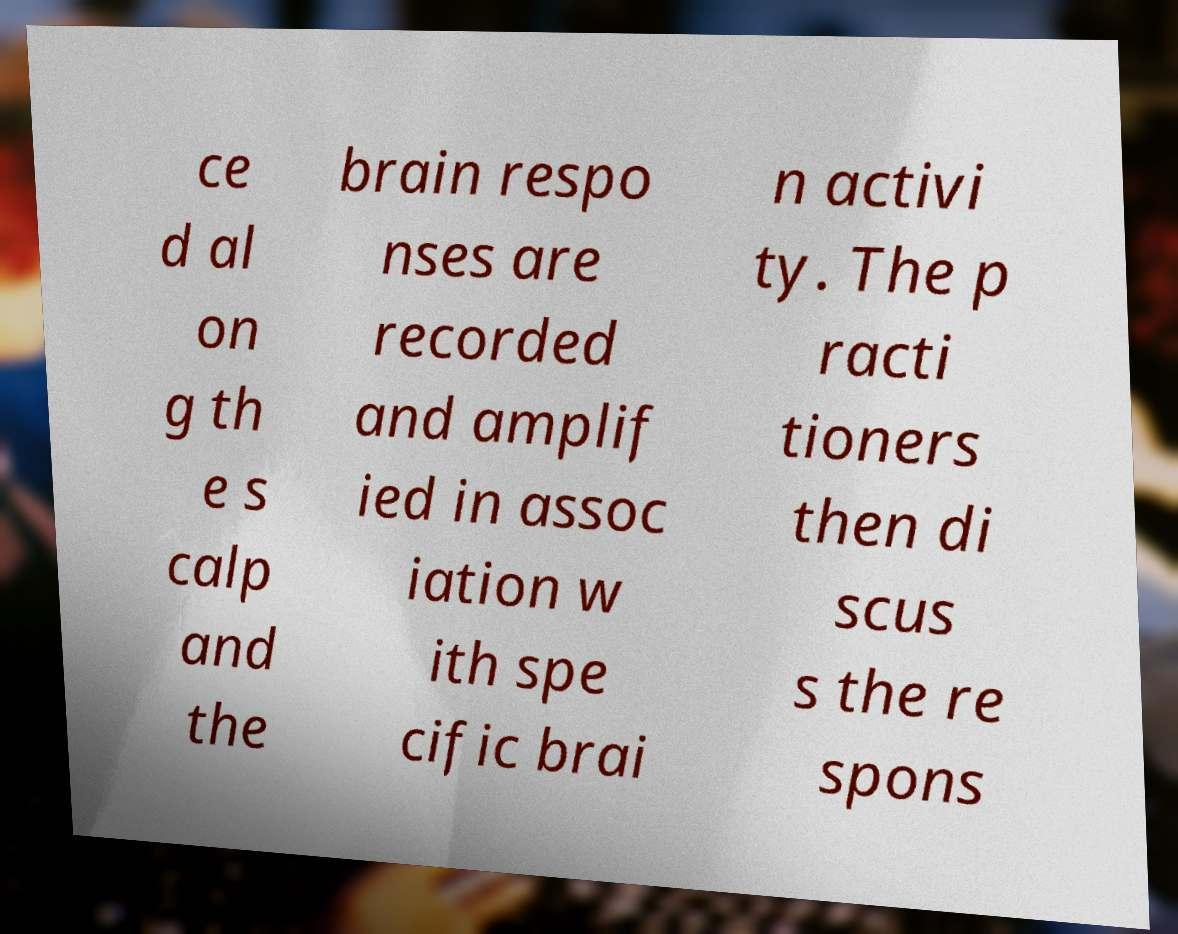What messages or text are displayed in this image? I need them in a readable, typed format. ce d al on g th e s calp and the brain respo nses are recorded and amplif ied in assoc iation w ith spe cific brai n activi ty. The p racti tioners then di scus s the re spons 